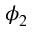<formula> <loc_0><loc_0><loc_500><loc_500>\phi _ { 2 }</formula> 